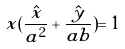<formula> <loc_0><loc_0><loc_500><loc_500>x ( \frac { \hat { x } } { a ^ { 2 } } + \frac { \hat { y } } { a b } ) = 1</formula> 